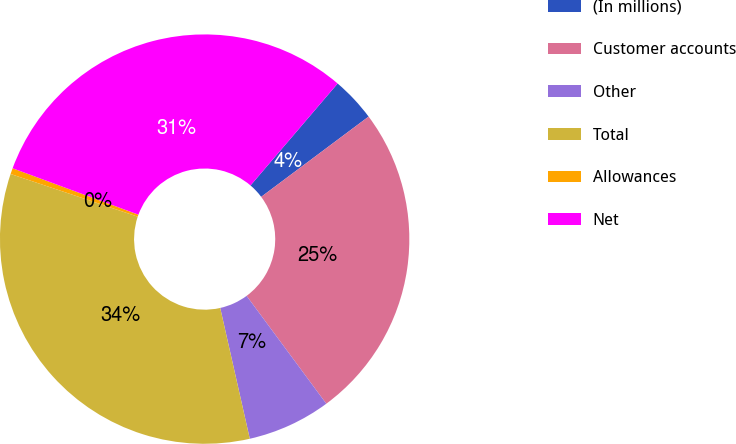<chart> <loc_0><loc_0><loc_500><loc_500><pie_chart><fcel>(In millions)<fcel>Customer accounts<fcel>Other<fcel>Total<fcel>Allowances<fcel>Net<nl><fcel>3.53%<fcel>25.08%<fcel>6.59%<fcel>33.69%<fcel>0.47%<fcel>30.63%<nl></chart> 